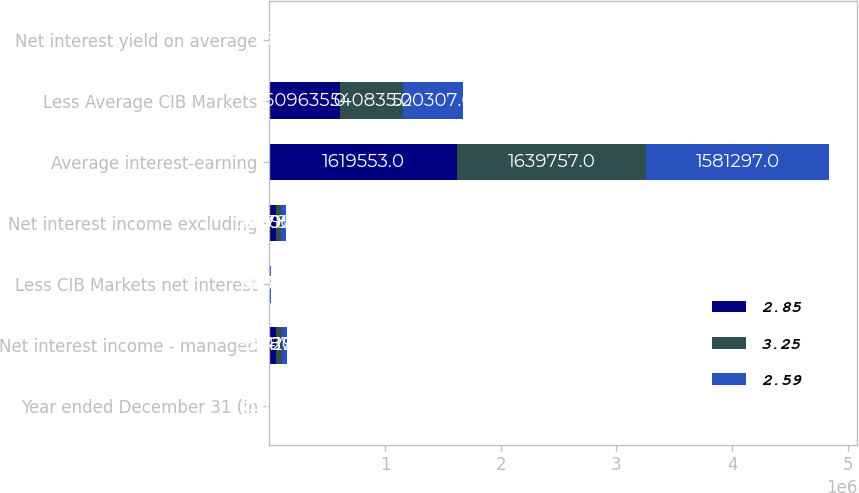Convert chart. <chart><loc_0><loc_0><loc_500><loc_500><stacked_bar_chart><ecel><fcel>Year ended December 31 (in<fcel>Net interest income - managed<fcel>Less CIB Markets net interest<fcel>Net interest income excluding<fcel>Average interest-earning<fcel>Less Average CIB Markets<fcel>Net interest yield on average<nl><fcel>2.85<fcel>2018<fcel>55687<fcel>3087<fcel>52600<fcel>1.61955e+06<fcel>609635<fcel>2.5<nl><fcel>3.25<fcel>2017<fcel>51410<fcel>4630<fcel>46780<fcel>1.63976e+06<fcel>540835<fcel>2.36<nl><fcel>2.59<fcel>2016<fcel>47292<fcel>6334<fcel>40958<fcel>1.5813e+06<fcel>520307<fcel>2.25<nl></chart> 